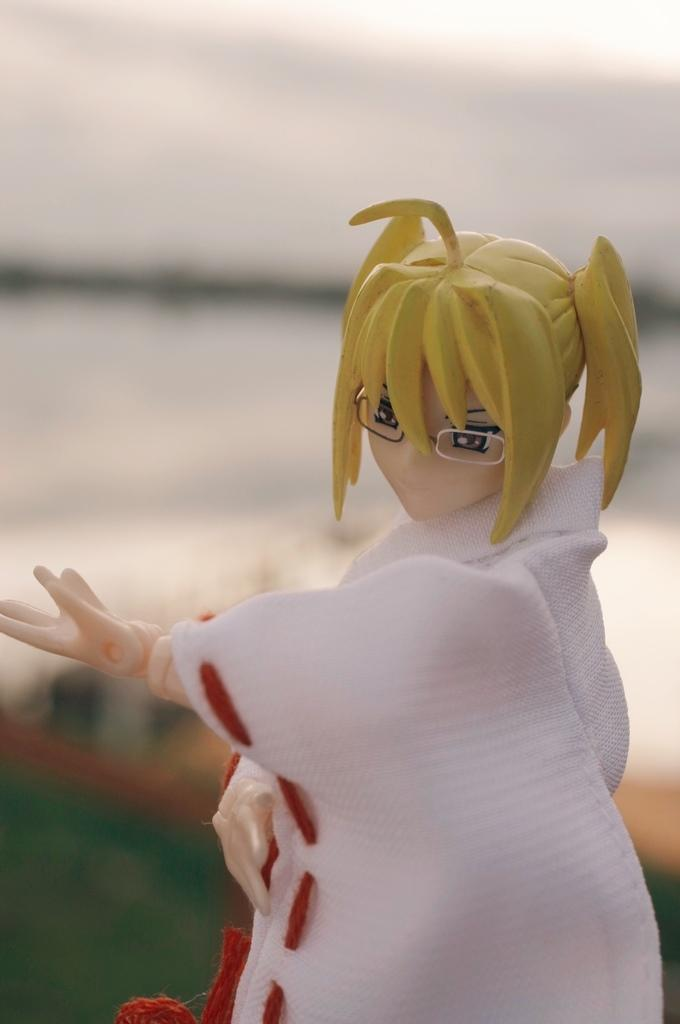What is the main subject of the image? There is a doll in the image. How is the doll dressed? The doll is dressed in white cloth. Can you describe the background of the image? The background of the image is blurred. What type of beetle can be seen crawling on the doll's arm in the image? There is no beetle present on the doll's arm in the image. Is there a dog visible in the image? No, there is no dog present in the image. 